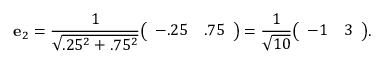Convert formula to latex. <formula><loc_0><loc_0><loc_500><loc_500>e _ { 2 } = { \frac { 1 } { \sqrt { . 2 5 ^ { 2 } + . 7 5 ^ { 2 } } } } { \left ( \begin{array} { l l } { - . 2 5 } & { . 7 5 } \end{array} \right ) } = { \frac { 1 } { \sqrt { 1 0 } } } { \left ( \begin{array} { l l } { - 1 } & { 3 } \end{array} \right ) } .</formula> 